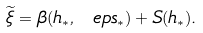Convert formula to latex. <formula><loc_0><loc_0><loc_500><loc_500>\widetilde { \xi } = \beta ( h _ { * } , \ e p s _ { * } ) + S ( h _ { * } ) .</formula> 